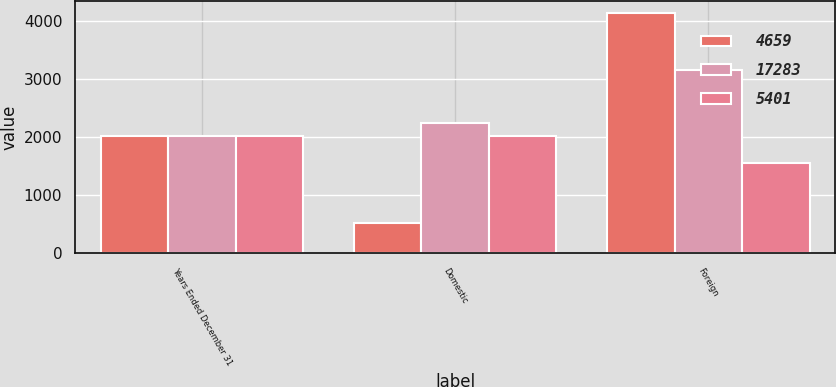Convert chart. <chart><loc_0><loc_0><loc_500><loc_500><stacked_bar_chart><ecel><fcel>Years Ended December 31<fcel>Domestic<fcel>Foreign<nl><fcel>4659<fcel>2016<fcel>518<fcel>4141<nl><fcel>17283<fcel>2015<fcel>2247<fcel>3154<nl><fcel>5401<fcel>2014<fcel>2015.5<fcel>1553<nl></chart> 